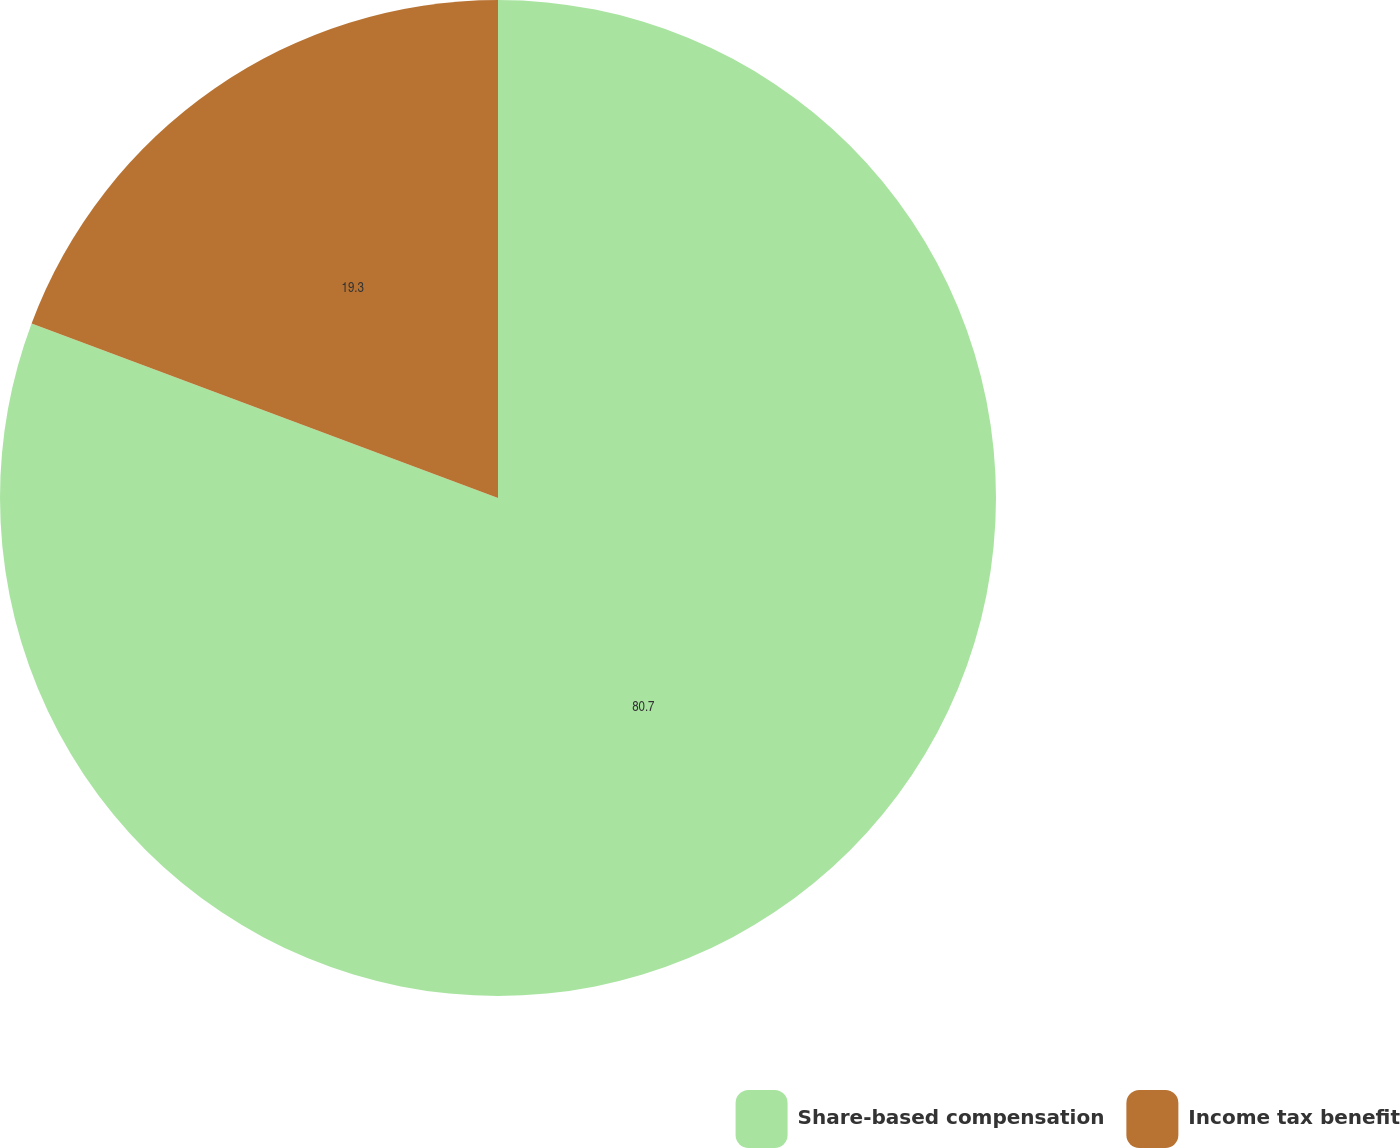Convert chart. <chart><loc_0><loc_0><loc_500><loc_500><pie_chart><fcel>Share-based compensation<fcel>Income tax benefit<nl><fcel>80.7%<fcel>19.3%<nl></chart> 